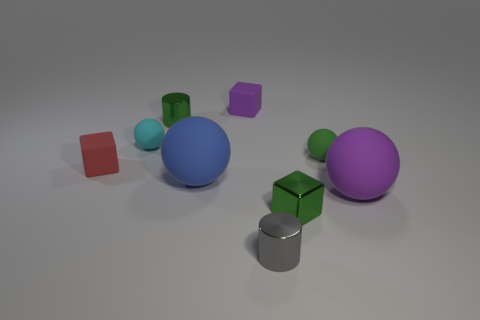What material is the small cylinder that is left of the big rubber sphere to the left of the purple cube?
Your response must be concise. Metal. There is a green thing that is the same shape as the gray metallic thing; what material is it?
Offer a very short reply. Metal. Is there a tiny metallic cylinder?
Provide a short and direct response. Yes. The small red thing that is made of the same material as the purple sphere is what shape?
Ensure brevity in your answer.  Cube. There is a small cyan thing that is to the right of the red matte cube; what is its material?
Make the answer very short. Rubber. There is a small metallic cylinder behind the small red thing; is its color the same as the small metal cube?
Your answer should be very brief. Yes. What is the size of the metallic thing on the left side of the cylinder right of the purple block?
Provide a short and direct response. Small. Is the number of tiny cyan rubber balls that are behind the blue rubber ball greater than the number of cylinders?
Offer a very short reply. No. Does the matte cube that is left of the blue matte sphere have the same size as the cyan rubber ball?
Ensure brevity in your answer.  Yes. There is a tiny metal thing that is behind the small gray metallic thing and to the right of the small purple object; what color is it?
Your response must be concise. Green. 